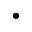Convert formula to latex. <formula><loc_0><loc_0><loc_500><loc_500>\bullet</formula> 